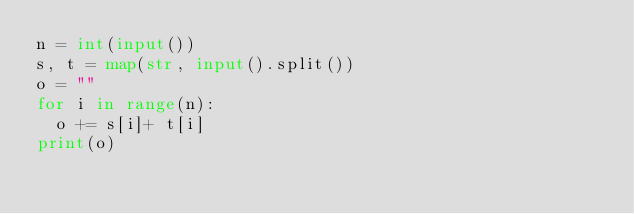<code> <loc_0><loc_0><loc_500><loc_500><_Python_>n = int(input())
s, t = map(str, input().split())
o = ""
for i in range(n):
  o += s[i]+ t[i]
print(o)</code> 